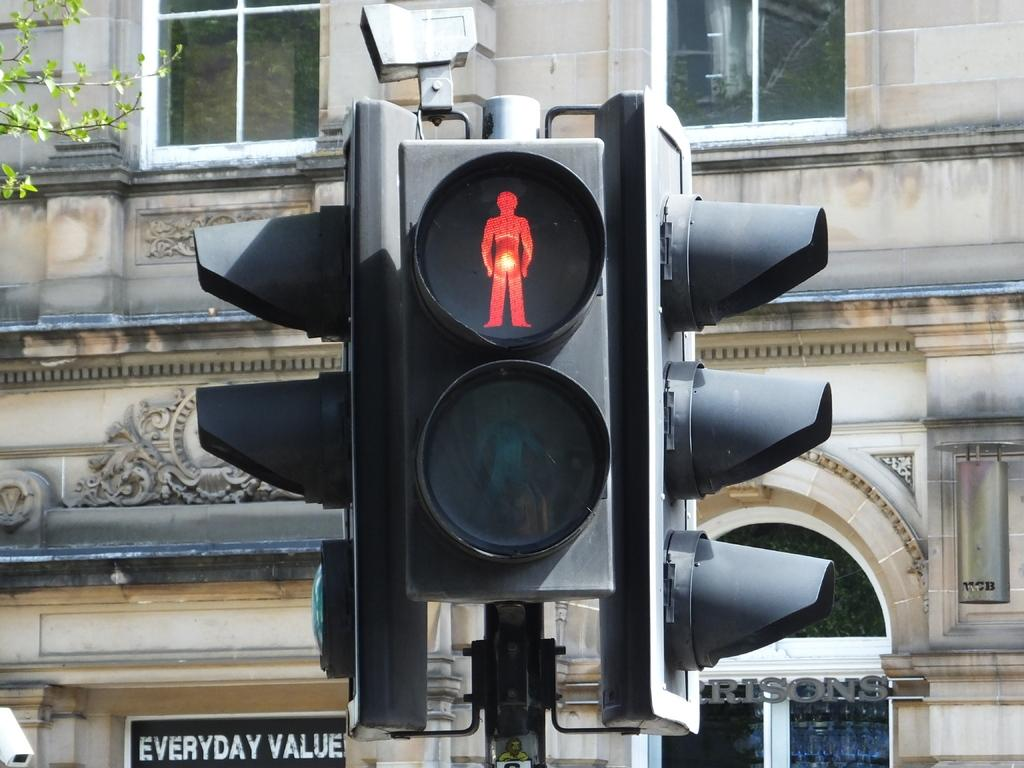Provide a one-sentence caption for the provided image. A stoplight with a sign next to it saying Everyday Value. 